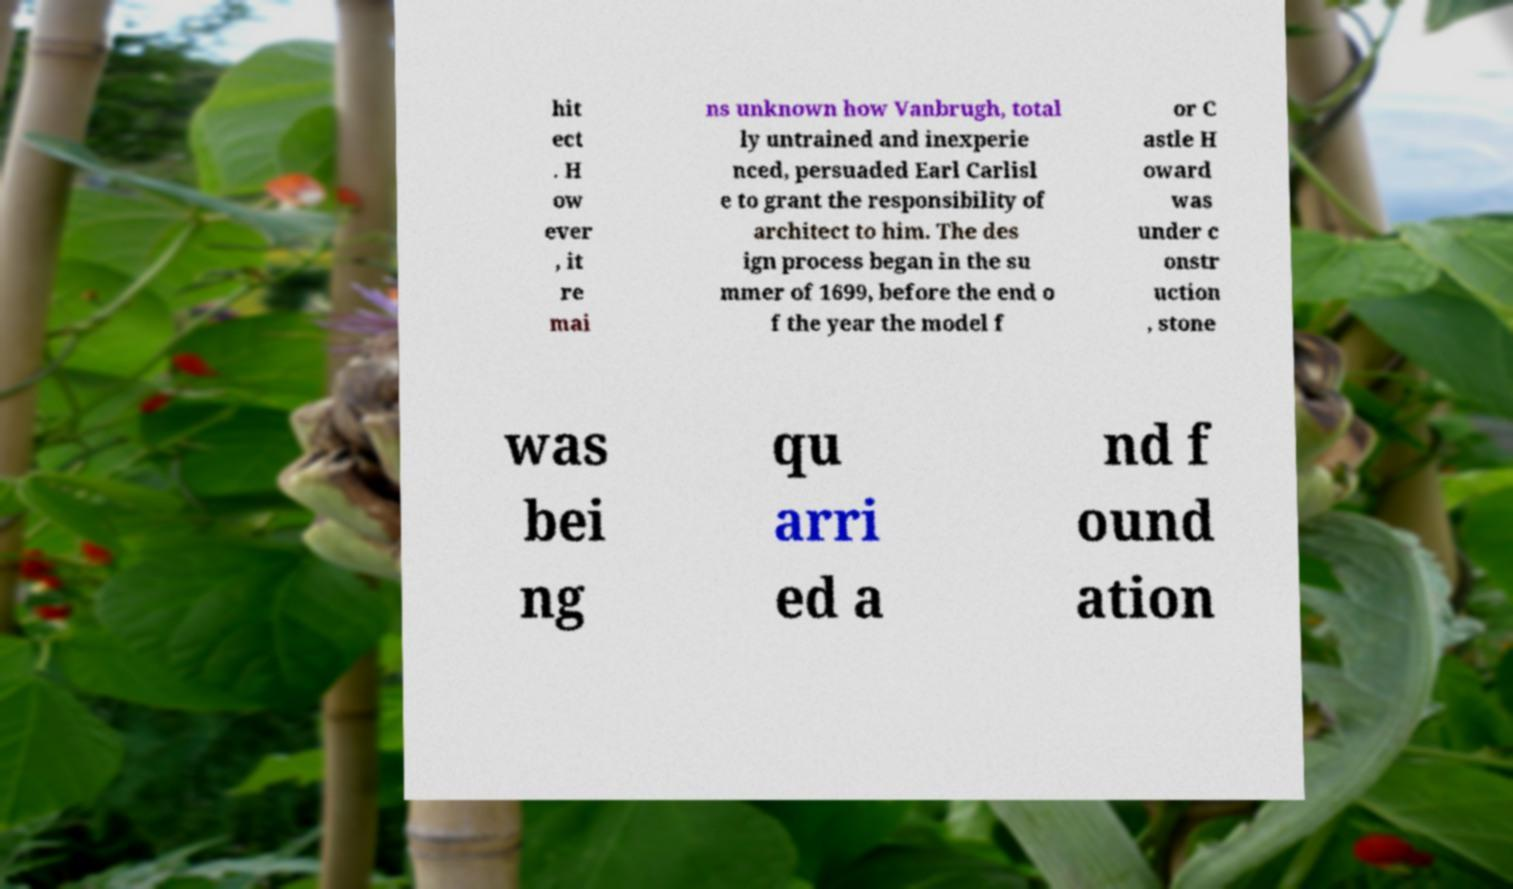What messages or text are displayed in this image? I need them in a readable, typed format. hit ect . H ow ever , it re mai ns unknown how Vanbrugh, total ly untrained and inexperie nced, persuaded Earl Carlisl e to grant the responsibility of architect to him. The des ign process began in the su mmer of 1699, before the end o f the year the model f or C astle H oward was under c onstr uction , stone was bei ng qu arri ed a nd f ound ation 